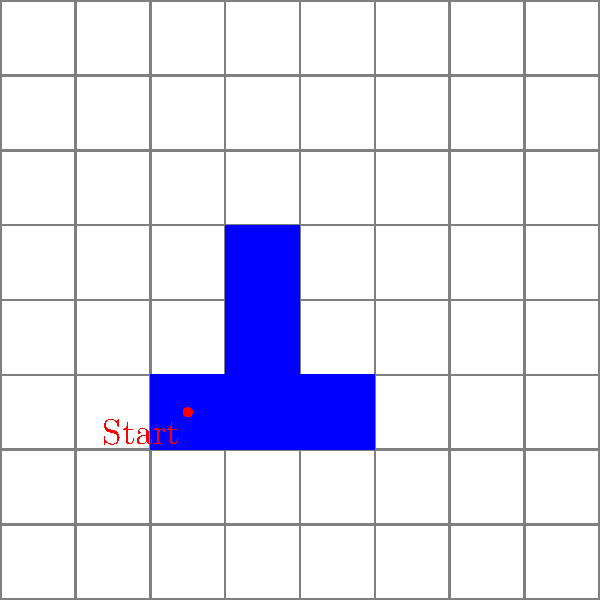Given a 2D bitmap image represented by an 8x8 grid, where blue cells represent colored pixels and white cells represent empty pixels, implement a flood fill algorithm starting from the point marked in red. What is the time complexity of this operation in terms of the total number of pixels $(n)$ in the image? To analyze the time complexity of the flood fill algorithm for this 2D bitmap image, let's break it down step-by-step:

1. The flood fill algorithm typically uses either a depth-first search (DFS) or breadth-first search (BFS) approach.

2. In the worst-case scenario, the algorithm might need to visit every pixel in the image. This occurs when the starting pixel is part of a large connected component that spans the entire image.

3. For each pixel visited, the algorithm performs the following operations:
   a. Check if the pixel is within the image boundaries.
   b. Check if the pixel has already been visited.
   c. Check if the pixel matches the target color (in this case, white).
   d. If conditions are met, change the pixel color and add its neighbors to the queue/stack.

4. Each of these operations takes constant time, $O(1)$.

5. In the worst case, the algorithm visits each pixel once and performs constant-time operations for each visit.

6. The total number of pixels in the image is $n = 8 \times 8 = 64$ in this example, but we'll use $n$ for the general case.

7. Therefore, the time complexity of the flood fill algorithm is proportional to the number of pixels in the image.

Thus, the overall time complexity of the flood fill algorithm for a 2D bitmap image is $O(n)$, where $n$ is the total number of pixels in the image.
Answer: $O(n)$ 